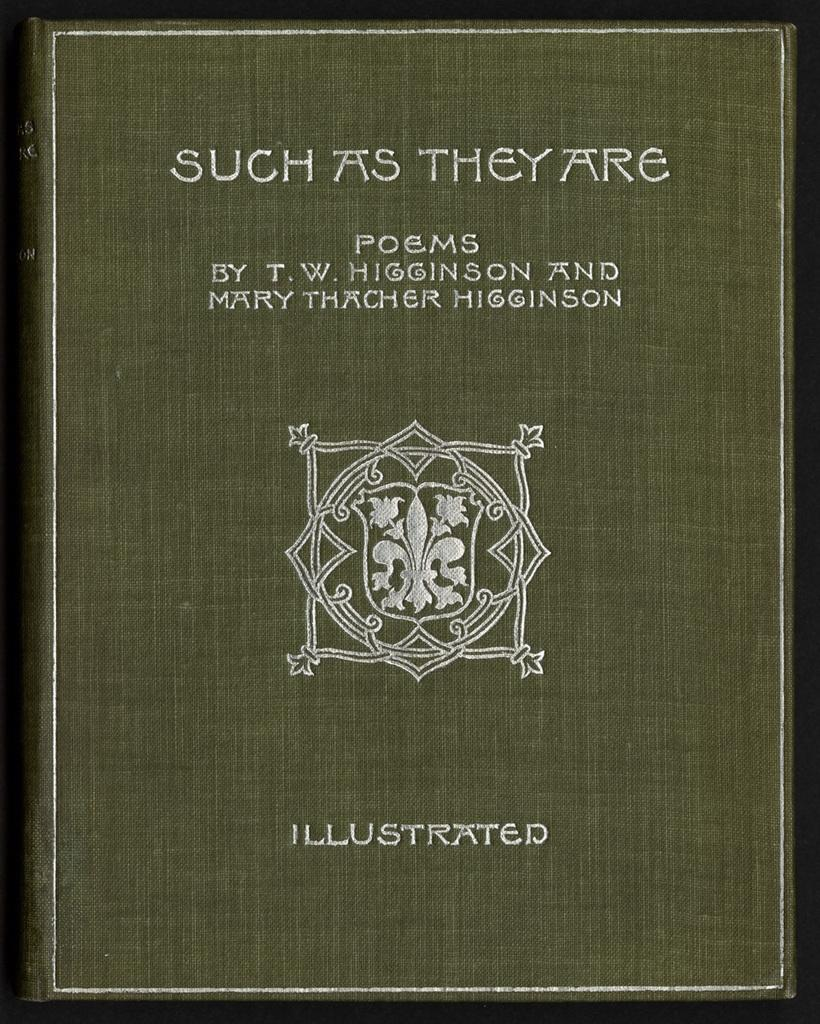<image>
Provide a brief description of the given image. An illustrated copy of a book of poems with a symbol on the cover. 